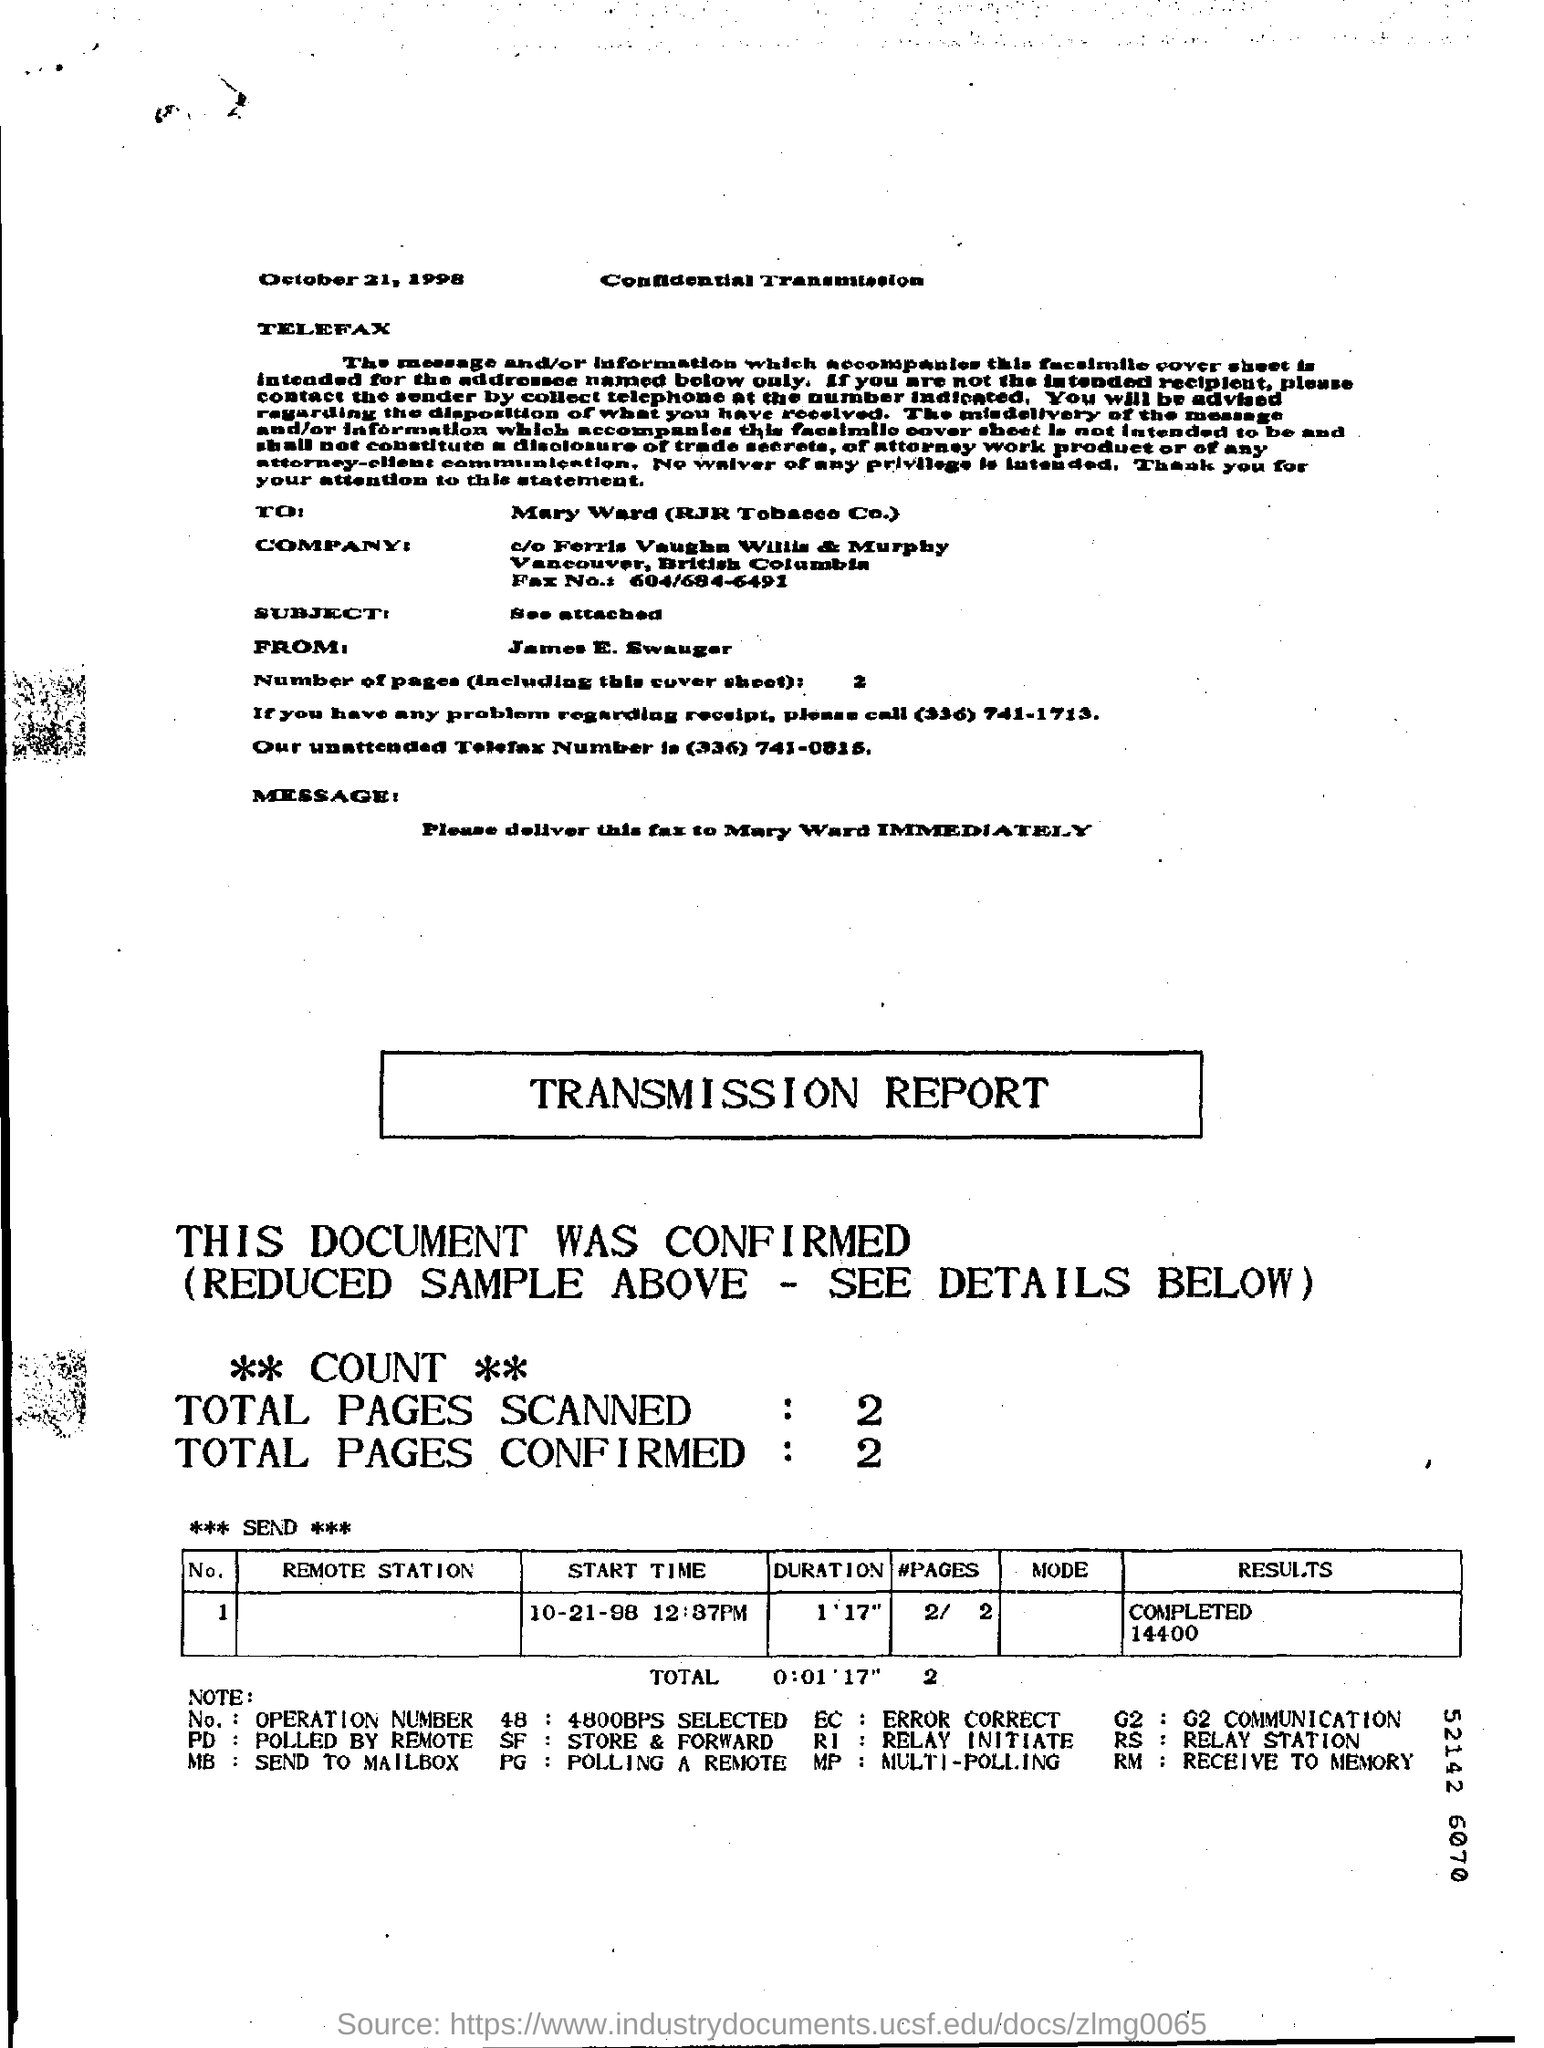What is the date on the document?
Keep it short and to the point. October 21, 1998. 